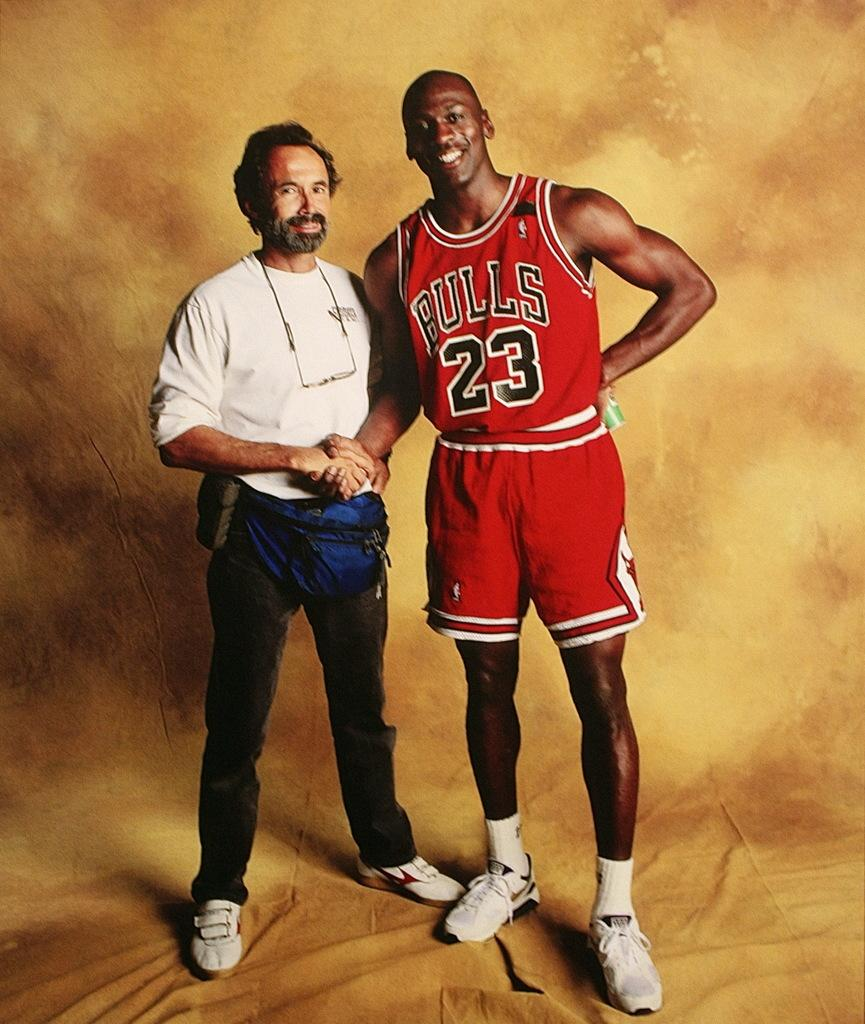<image>
Provide a brief description of the given image. Michael Jordan in his Bulls uniform posing with another man. 